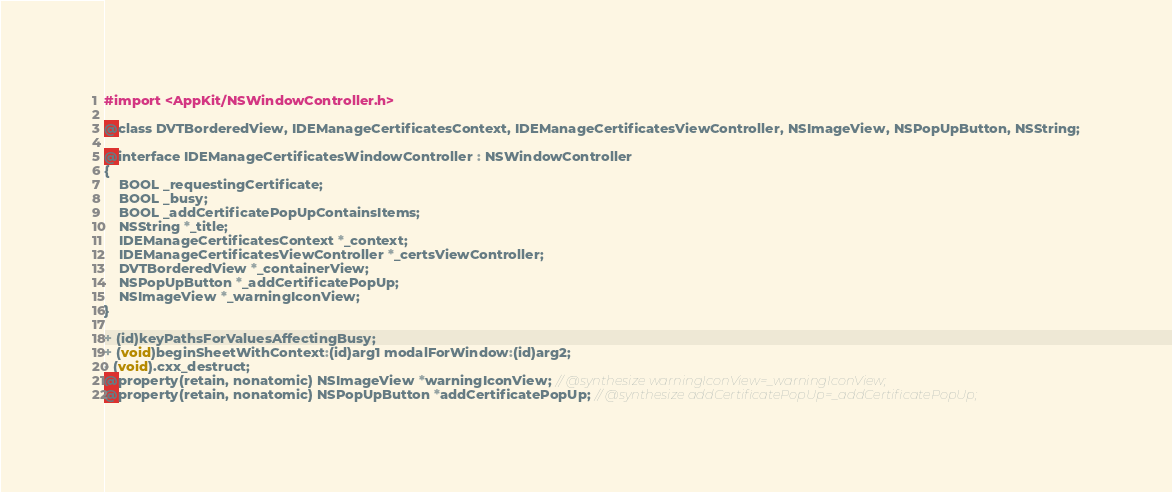Convert code to text. <code><loc_0><loc_0><loc_500><loc_500><_C_>#import <AppKit/NSWindowController.h>

@class DVTBorderedView, IDEManageCertificatesContext, IDEManageCertificatesViewController, NSImageView, NSPopUpButton, NSString;

@interface IDEManageCertificatesWindowController : NSWindowController
{
    BOOL _requestingCertificate;
    BOOL _busy;
    BOOL _addCertificatePopUpContainsItems;
    NSString *_title;
    IDEManageCertificatesContext *_context;
    IDEManageCertificatesViewController *_certsViewController;
    DVTBorderedView *_containerView;
    NSPopUpButton *_addCertificatePopUp;
    NSImageView *_warningIconView;
}

+ (id)keyPathsForValuesAffectingBusy;
+ (void)beginSheetWithContext:(id)arg1 modalForWindow:(id)arg2;
- (void).cxx_destruct;
@property(retain, nonatomic) NSImageView *warningIconView; // @synthesize warningIconView=_warningIconView;
@property(retain, nonatomic) NSPopUpButton *addCertificatePopUp; // @synthesize addCertificatePopUp=_addCertificatePopUp;</code> 